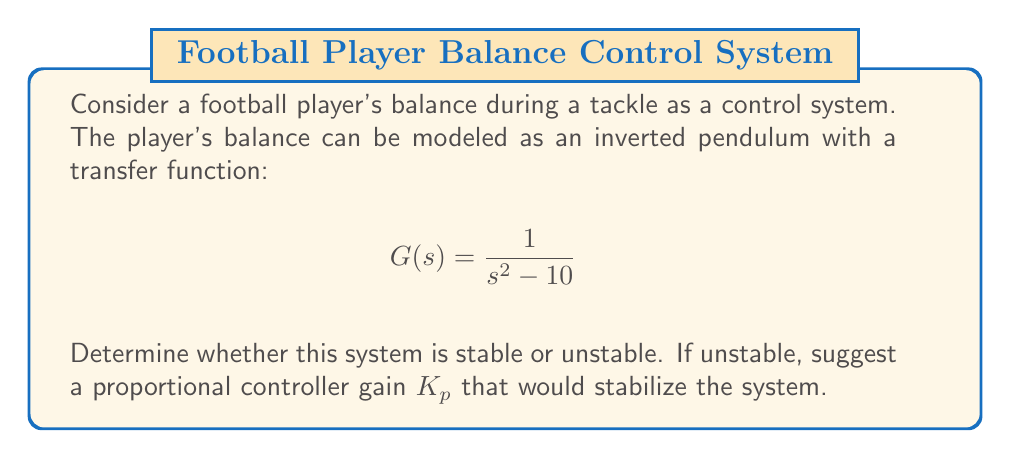Could you help me with this problem? To analyze the stability of this system, we need to examine its poles:

1. The characteristic equation is the denominator of the transfer function set to zero:
   $$s^2 - 10 = 0$$

2. Solve for s:
   $$s = \pm \sqrt{10} = \pm 3.16$$

3. The system has two poles: one at +3.16 and one at -3.16. A system is unstable if it has any poles in the right-half plane of the s-plane. Since we have a positive pole, this system is unstable.

4. To stabilize the system, we can use a proportional controller with gain $K_p$. The new transfer function becomes:

   $$G_c(s) = \frac{K_p}{s^2 - 10}$$

5. The new characteristic equation is:
   $$s^2 + K_p - 10 = 0$$

6. For stability, we need both roots to be in the left-half plane. Using the Routh-Hurwitz criterion, we need:
   $$K_p > 10$$

7. Any value of $K_p$ greater than 10 will stabilize the system. For example, we can choose $K_p = 15$.

8. With $K_p = 15$, the new poles are:
   $$s = \frac{-15 \pm \sqrt{15^2 + 40}}{2} = -0.87 \text{ and } -4.13$$

   Both poles are now in the left-half plane, indicating a stable system.
Answer: The original system is unstable. A proportional controller with gain $K_p > 10$ (e.g., $K_p = 15$) will stabilize the system. 